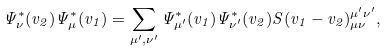<formula> <loc_0><loc_0><loc_500><loc_500>\Psi ^ { * } _ { \nu } ( v _ { 2 } ) \Psi ^ { * } _ { \mu } ( v _ { 1 } ) = \sum _ { \mu ^ { \prime } , \nu ^ { \prime } } \Psi ^ { * } _ { \mu ^ { \prime } } ( v _ { 1 } ) \Psi ^ { * } _ { \nu ^ { \prime } } ( v _ { 2 } ) S ( v _ { 1 } - v _ { 2 } ) _ { \mu \nu } ^ { \mu ^ { \prime } \nu ^ { \prime } } ,</formula> 